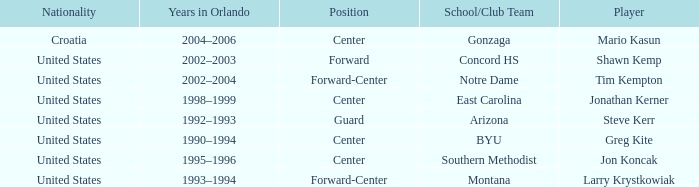What years in orlando have the United States as the nationality, and montana as the school/club team? 1993–1994. 